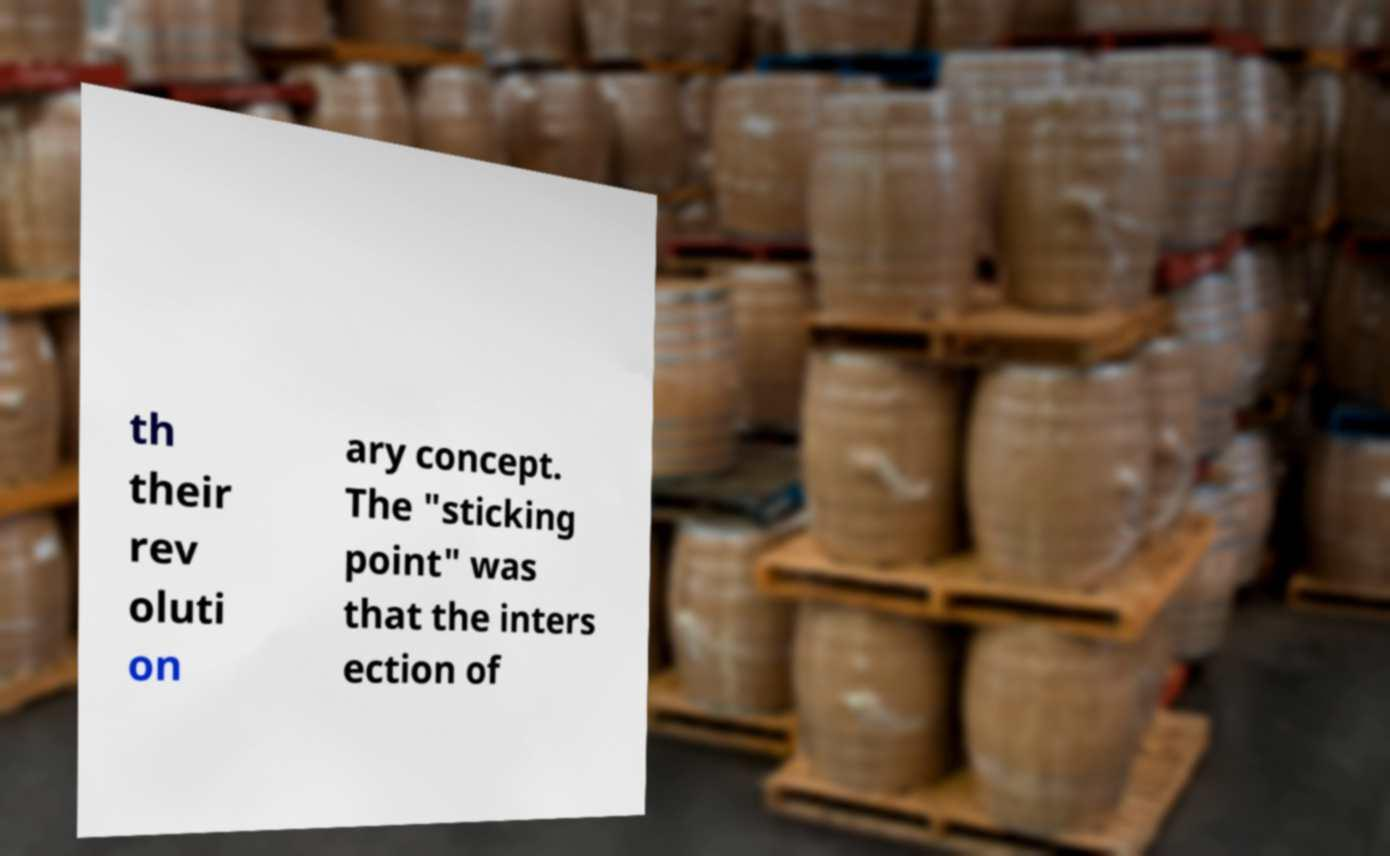Can you read and provide the text displayed in the image?This photo seems to have some interesting text. Can you extract and type it out for me? th their rev oluti on ary concept. The "sticking point" was that the inters ection of 